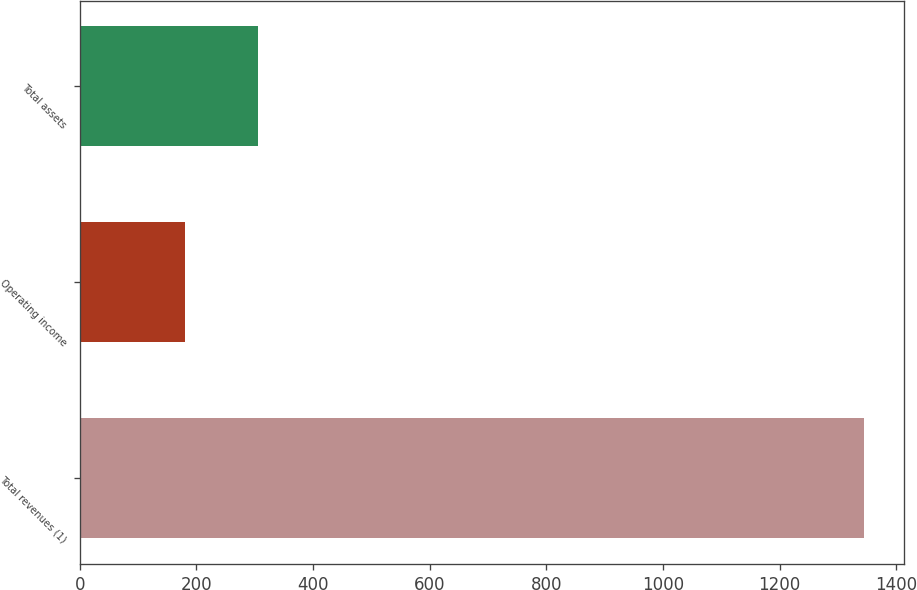<chart> <loc_0><loc_0><loc_500><loc_500><bar_chart><fcel>Total revenues (1)<fcel>Operating income<fcel>Total assets<nl><fcel>1345<fcel>180<fcel>305<nl></chart> 